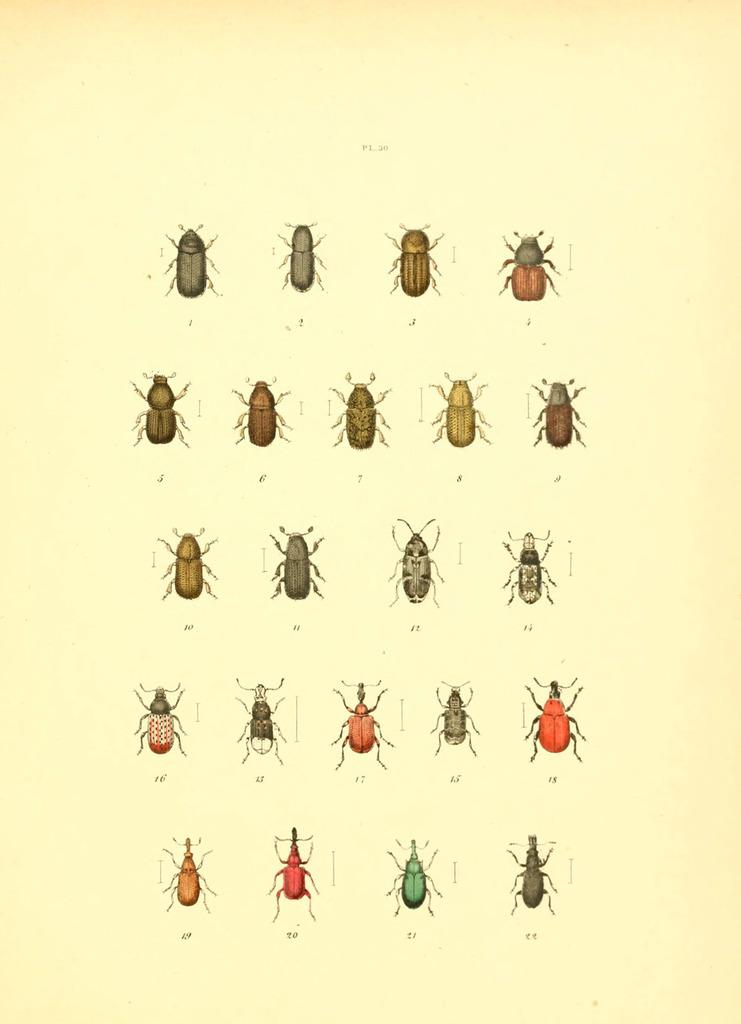What type of living organisms are featured in the image? The image contains pictures of insects. What type of basketball cloth is used to make the love letters in the image? There is no basketball cloth or love letters present in the image; it features pictures of insects. 